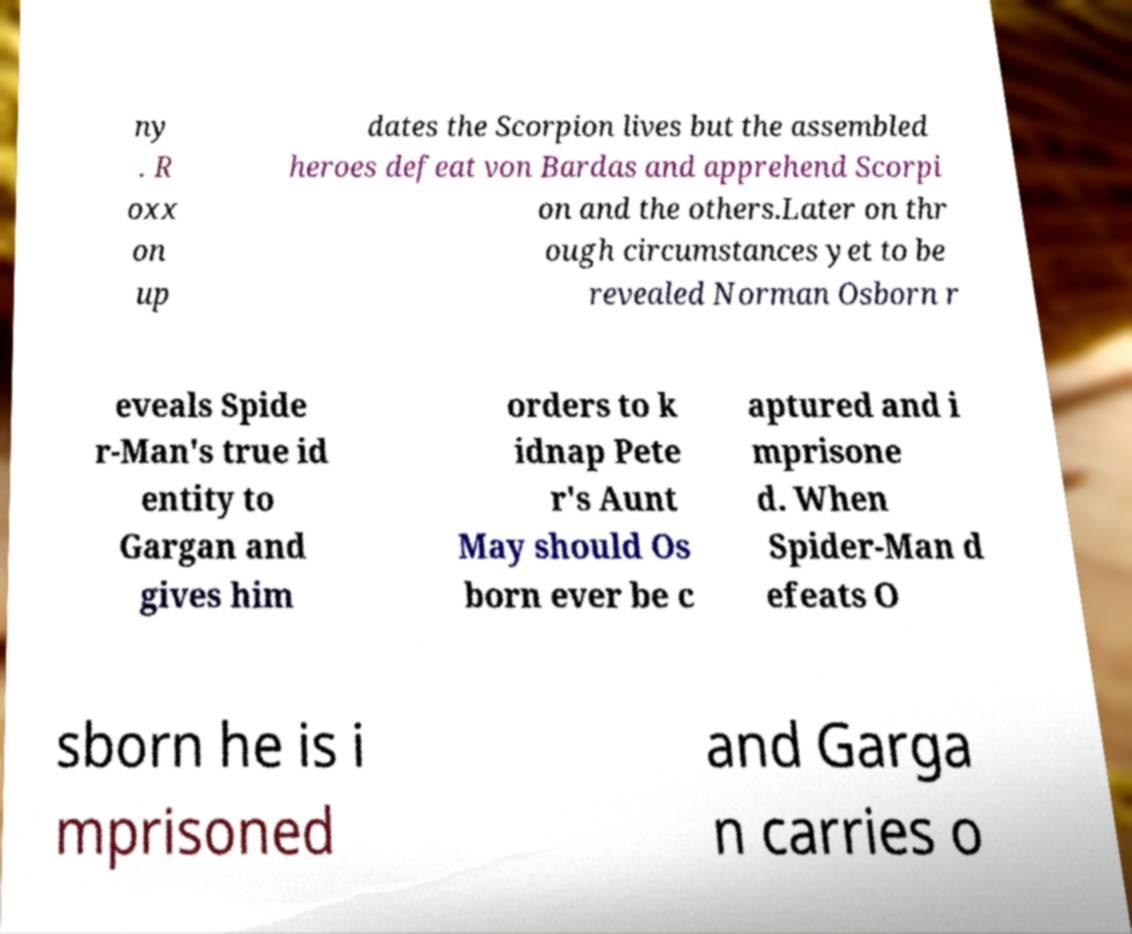I need the written content from this picture converted into text. Can you do that? ny . R oxx on up dates the Scorpion lives but the assembled heroes defeat von Bardas and apprehend Scorpi on and the others.Later on thr ough circumstances yet to be revealed Norman Osborn r eveals Spide r-Man's true id entity to Gargan and gives him orders to k idnap Pete r's Aunt May should Os born ever be c aptured and i mprisone d. When Spider-Man d efeats O sborn he is i mprisoned and Garga n carries o 